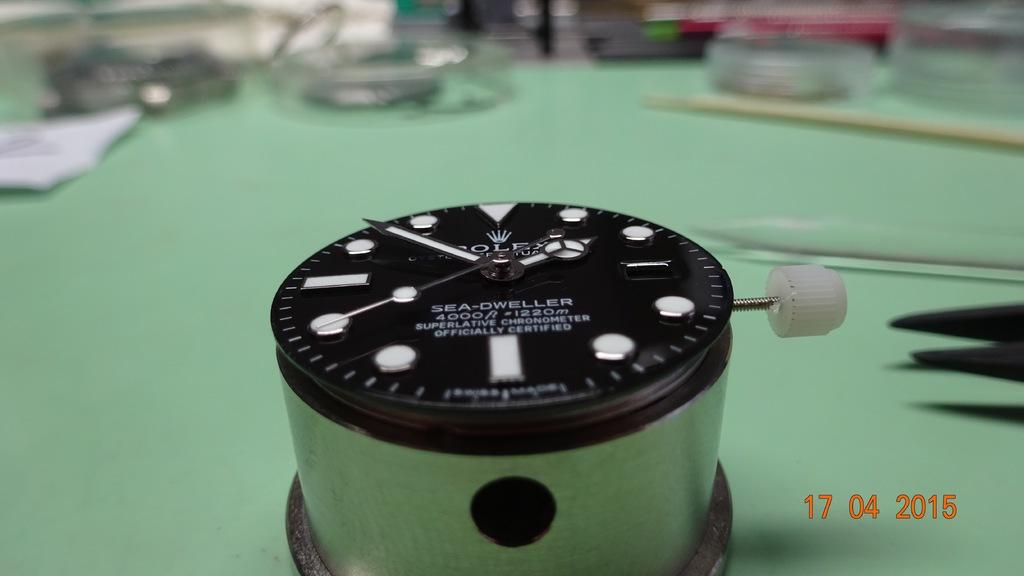Provide a one-sentence caption for the provided image. A clock like device called sea dweller sits on a green table. 